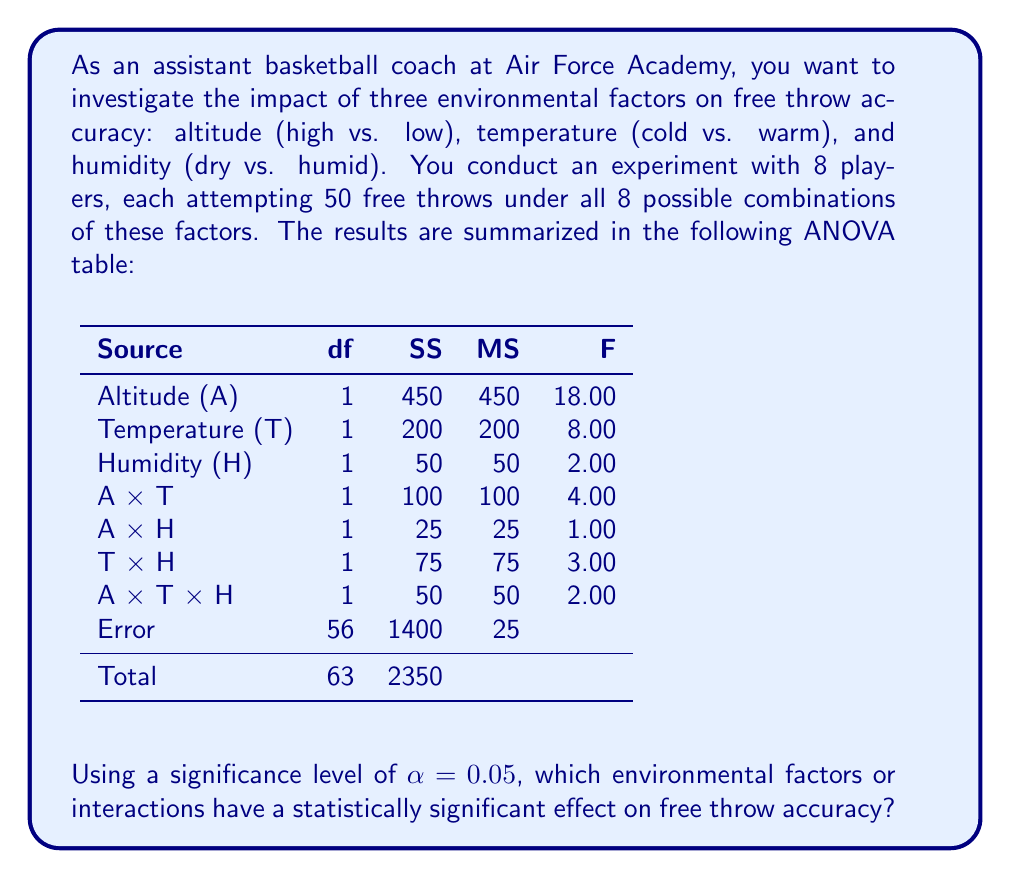Can you answer this question? To determine which factors or interactions have a statistically significant effect on free throw accuracy, we need to compare the F-values in the ANOVA table with the critical F-value.

Step 1: Determine the critical F-value
For $\alpha = 0.05$, with degrees of freedom $df_1 = 1$ (for each factor/interaction) and $df_2 = 56$ (error), the critical F-value is approximately 4.01.

Step 2: Compare F-values to the critical F-value
- Altitude (A): $F = 18.00 > 4.01$, significant
- Temperature (T): $F = 8.00 > 4.01$, significant
- Humidity (H): $F = 2.00 < 4.01$, not significant
- A × T interaction: $F = 4.00 < 4.01$, not significant (but very close)
- A × H interaction: $F = 1.00 < 4.01$, not significant
- T × H interaction: $F = 3.00 < 4.01$, not significant
- A × T × H interaction: $F = 2.00 < 4.01$, not significant

Step 3: Interpret the results
The factors that have a statistically significant effect on free throw accuracy are:
1. Altitude
2. Temperature

The interactions and humidity do not show a statistically significant effect at the 0.05 level.
Answer: Altitude and Temperature 